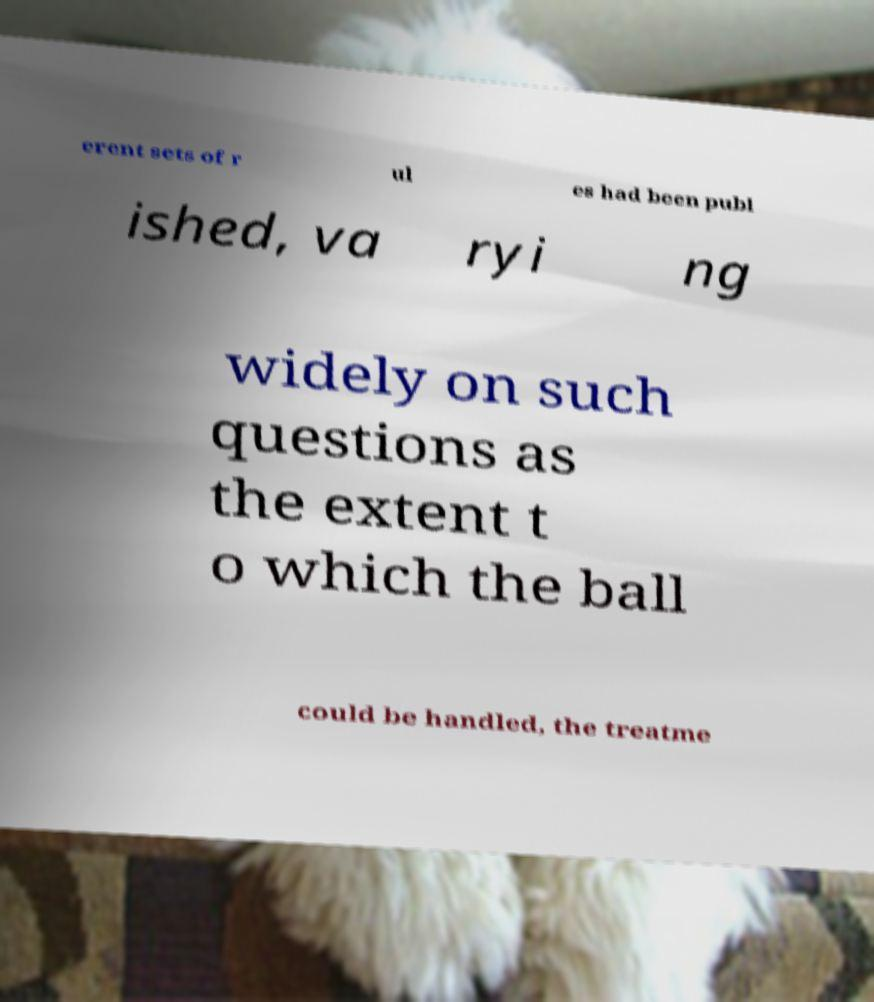Can you accurately transcribe the text from the provided image for me? erent sets of r ul es had been publ ished, va ryi ng widely on such questions as the extent t o which the ball could be handled, the treatme 